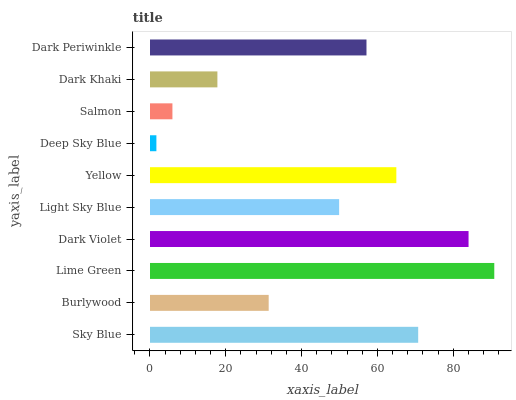Is Deep Sky Blue the minimum?
Answer yes or no. Yes. Is Lime Green the maximum?
Answer yes or no. Yes. Is Burlywood the minimum?
Answer yes or no. No. Is Burlywood the maximum?
Answer yes or no. No. Is Sky Blue greater than Burlywood?
Answer yes or no. Yes. Is Burlywood less than Sky Blue?
Answer yes or no. Yes. Is Burlywood greater than Sky Blue?
Answer yes or no. No. Is Sky Blue less than Burlywood?
Answer yes or no. No. Is Dark Periwinkle the high median?
Answer yes or no. Yes. Is Light Sky Blue the low median?
Answer yes or no. Yes. Is Dark Violet the high median?
Answer yes or no. No. Is Sky Blue the low median?
Answer yes or no. No. 